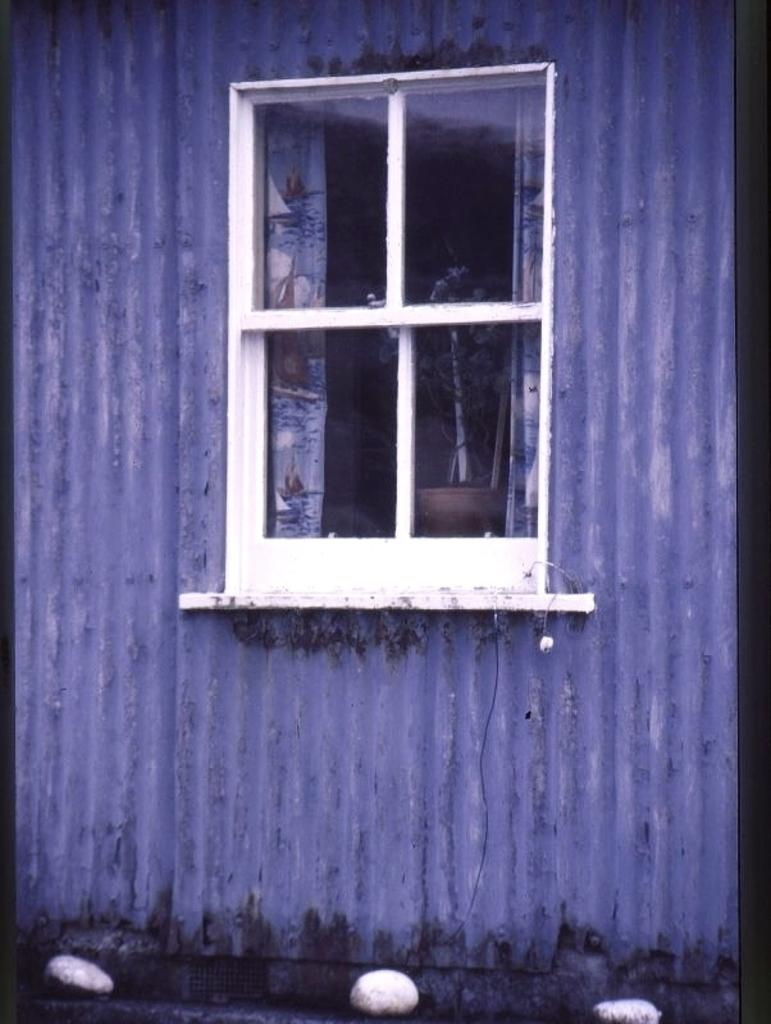What can be seen through the window in the image? A plant in a pot is visible from the window. What type of window treatment is present in the image? There are curtains associated with the window. What is on the floor in the image? Stones are present on the floor. What type of fold can be seen in the plant's leaves in the image? There is no fold in the plant's leaves visible in the image, as the plant is in a pot and not shown in detail. 